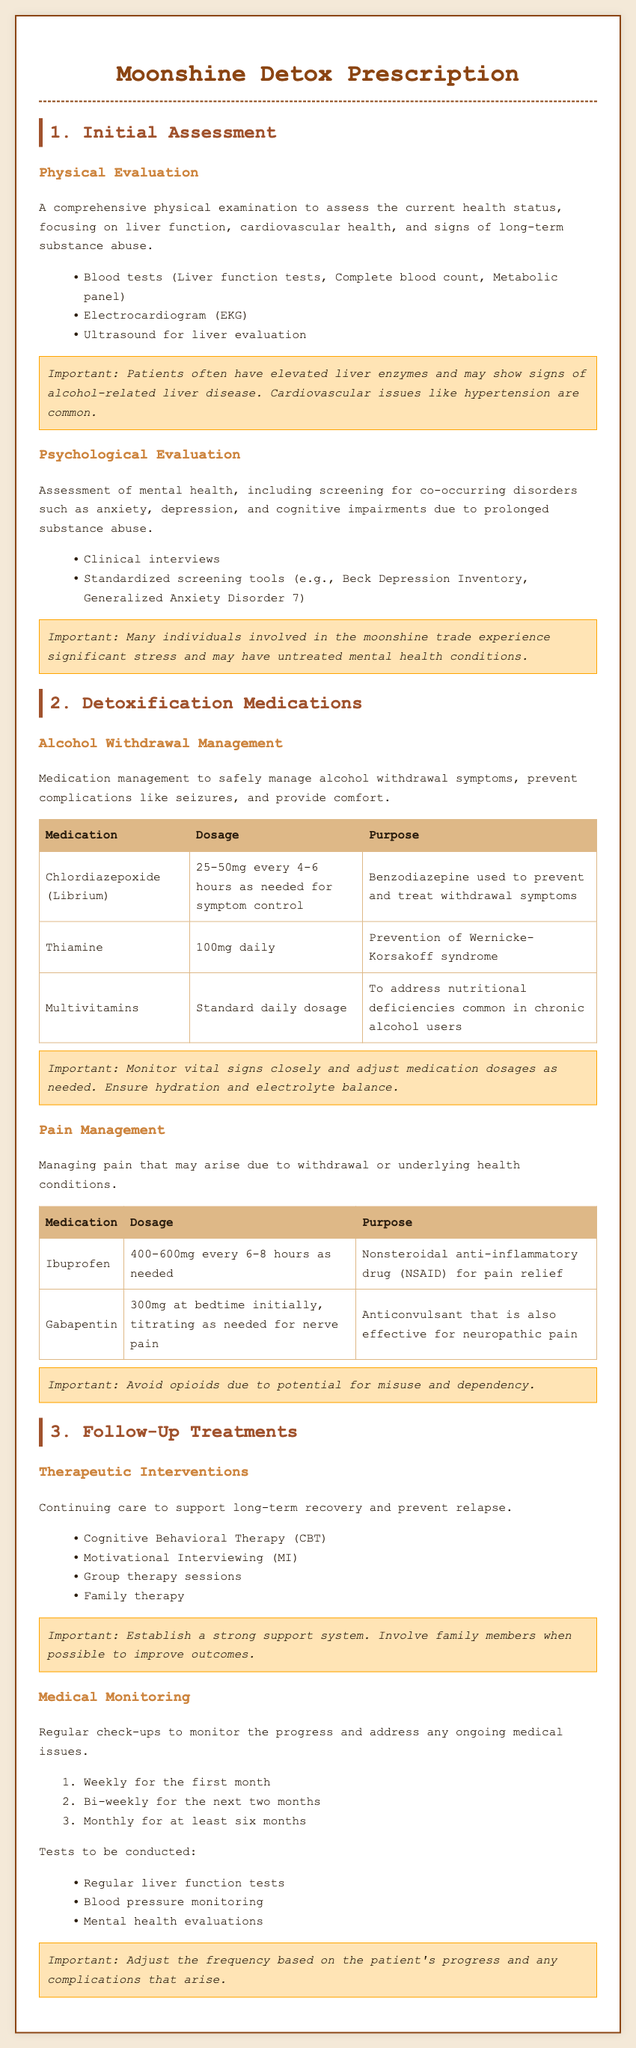What is the purpose of the initial assessment? The initial assessment is to evaluate the current health status, focusing on liver function, cardiovascular health, and signs of long-term substance abuse.
Answer: Evaluate health status What is the dosage of Chlordiazepoxide for alcohol withdrawal management? The dosage for Chlordiazepoxide is 25-50mg every 4-6 hours as needed for symptom control.
Answer: 25-50mg every 4-6 hours How often should medical monitoring occur for the first month? Medical monitoring should occur weekly for the first month.
Answer: Weekly What are two medications used for pain management in this prescription? Pain management includes Ibuprofen and Gabapentin.
Answer: Ibuprofen and Gabapentin What screening tool is mentioned for anxiety assessment? The Generalized Anxiety Disorder 7 is mentioned as a screening tool for anxiety.
Answer: Generalized Anxiety Disorder 7 What supportive therapy is listed as a follow-up treatment? Cognitive Behavioral Therapy (CBT) is listed as a follow-up treatment.
Answer: Cognitive Behavioral Therapy (CBT) How many total follow-up visits are required in the first three months? The total follow-up visits required in the first three months is seven (4 weekly + 6 bi-weekly).
Answer: Seven What is the daily dosage of Thiamine in the detox program? The daily dosage of Thiamine is 100mg.
Answer: 100mg What is the goal of the psychological evaluation? The goal is to assess mental health and screen for co-occurring disorders.
Answer: Assess mental health 